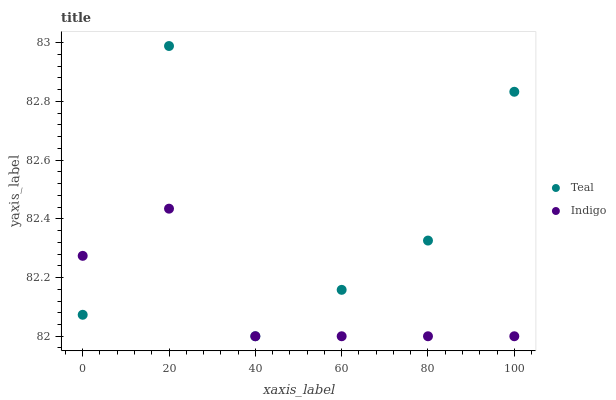Does Indigo have the minimum area under the curve?
Answer yes or no. Yes. Does Teal have the maximum area under the curve?
Answer yes or no. Yes. Does Teal have the minimum area under the curve?
Answer yes or no. No. Is Indigo the smoothest?
Answer yes or no. Yes. Is Teal the roughest?
Answer yes or no. Yes. Is Teal the smoothest?
Answer yes or no. No. Does Indigo have the lowest value?
Answer yes or no. Yes. Does Teal have the highest value?
Answer yes or no. Yes. Does Teal intersect Indigo?
Answer yes or no. Yes. Is Teal less than Indigo?
Answer yes or no. No. Is Teal greater than Indigo?
Answer yes or no. No. 